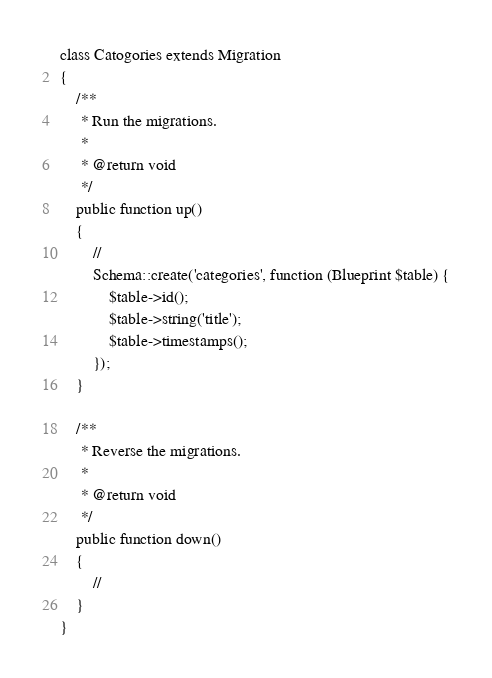<code> <loc_0><loc_0><loc_500><loc_500><_PHP_>
class Catogories extends Migration
{
    /**
     * Run the migrations.
     *
     * @return void
     */
    public function up()
    {
        //
        Schema::create('categories', function (Blueprint $table) {
            $table->id();
            $table->string('title');
            $table->timestamps();
        });
    }

    /**
     * Reverse the migrations.
     *
     * @return void
     */
    public function down()
    {
        //
    }
}
</code> 